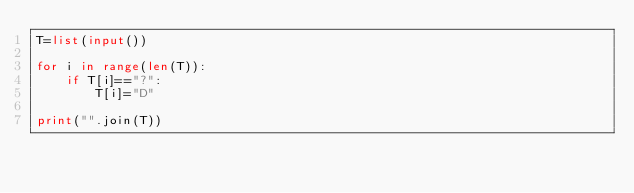Convert code to text. <code><loc_0><loc_0><loc_500><loc_500><_Python_>T=list(input())

for i in range(len(T)):
	if T[i]=="?":
		T[i]="D"

print("".join(T))
</code> 